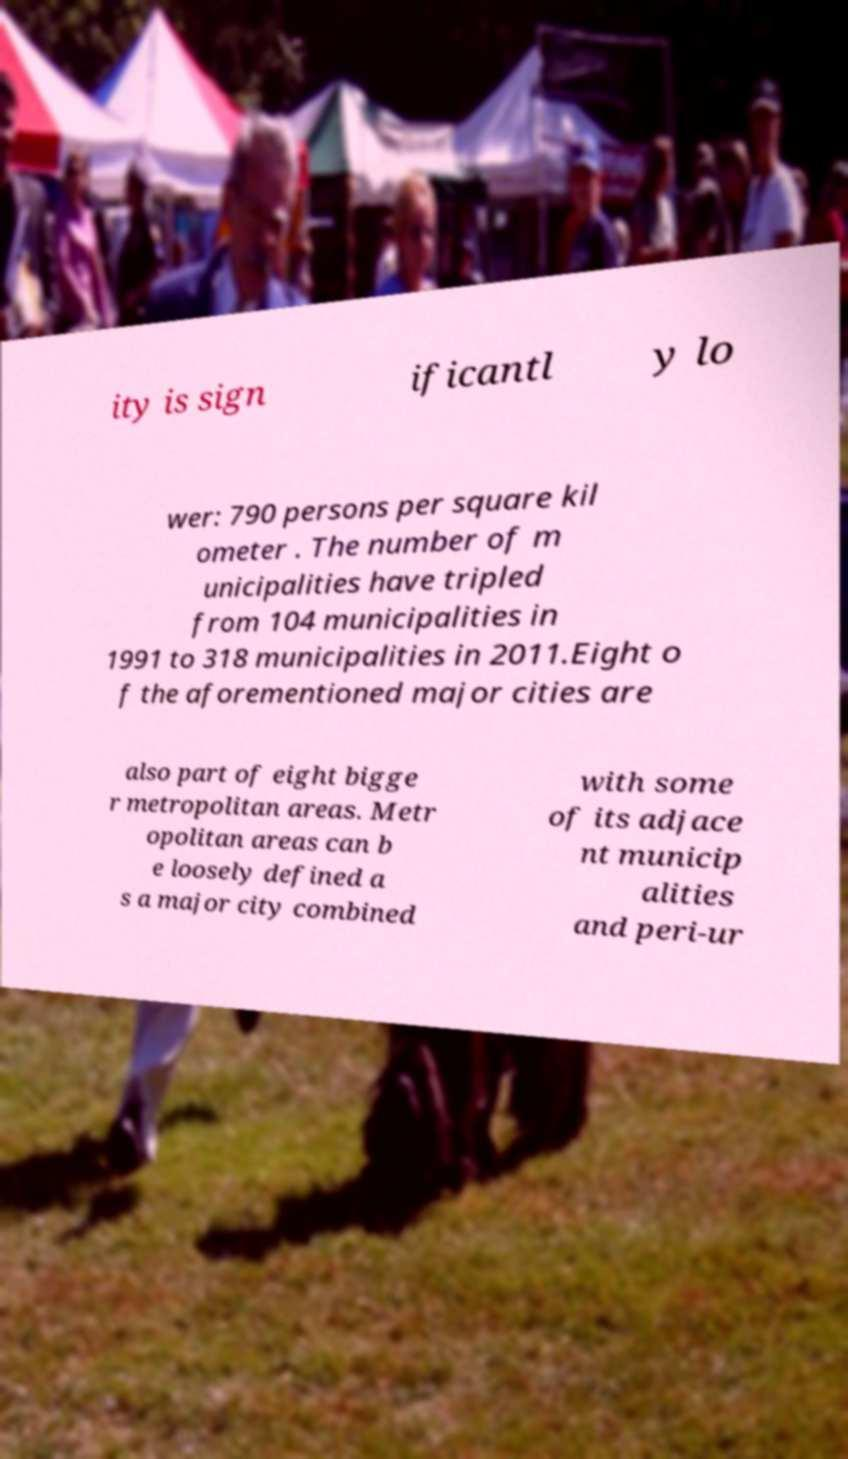What messages or text are displayed in this image? I need them in a readable, typed format. ity is sign ificantl y lo wer: 790 persons per square kil ometer . The number of m unicipalities have tripled from 104 municipalities in 1991 to 318 municipalities in 2011.Eight o f the aforementioned major cities are also part of eight bigge r metropolitan areas. Metr opolitan areas can b e loosely defined a s a major city combined with some of its adjace nt municip alities and peri-ur 